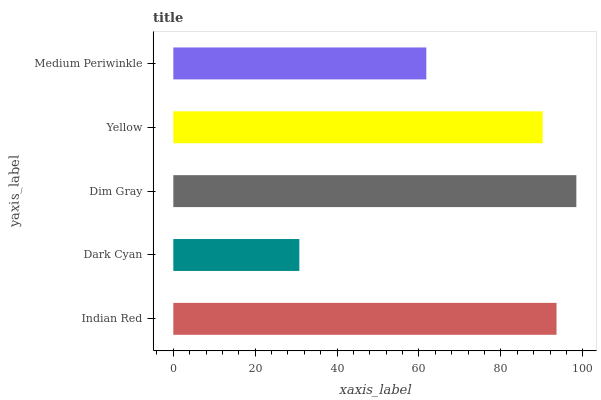Is Dark Cyan the minimum?
Answer yes or no. Yes. Is Dim Gray the maximum?
Answer yes or no. Yes. Is Dim Gray the minimum?
Answer yes or no. No. Is Dark Cyan the maximum?
Answer yes or no. No. Is Dim Gray greater than Dark Cyan?
Answer yes or no. Yes. Is Dark Cyan less than Dim Gray?
Answer yes or no. Yes. Is Dark Cyan greater than Dim Gray?
Answer yes or no. No. Is Dim Gray less than Dark Cyan?
Answer yes or no. No. Is Yellow the high median?
Answer yes or no. Yes. Is Yellow the low median?
Answer yes or no. Yes. Is Medium Periwinkle the high median?
Answer yes or no. No. Is Indian Red the low median?
Answer yes or no. No. 